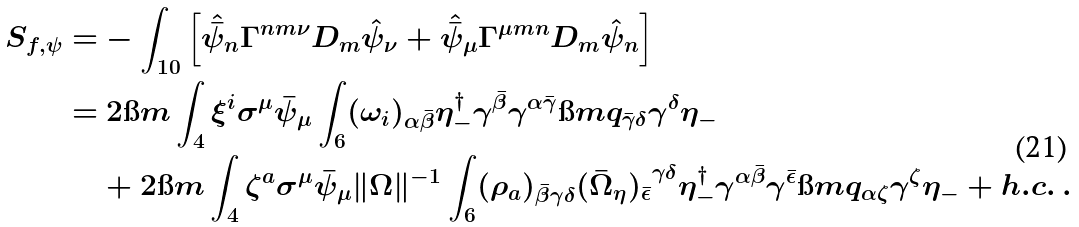<formula> <loc_0><loc_0><loc_500><loc_500>S _ { f , \psi } = & - \int _ { 1 0 } \left [ \hat { \bar { \psi } } _ { n } \Gamma ^ { n m \nu } D _ { m } \hat { \psi } _ { \nu } + \hat { \bar { \psi } } _ { \mu } \Gamma ^ { \mu m n } D _ { m } \hat { \psi } _ { n } \right ] \\ = & \ 2 \i m \int _ { 4 } \xi ^ { i } \sigma ^ { \mu } \bar { \psi } _ { \mu } \int _ { 6 } ( \omega _ { i } ) _ { \alpha \bar { \beta } } \eta ^ { \dag } _ { - } \gamma ^ { \bar { \beta } } \gamma ^ { \alpha \bar { \gamma } } \i m q _ { \bar { \gamma } \delta } \gamma ^ { \delta } \eta _ { - } \\ & + 2 \i m \int _ { 4 } \zeta ^ { a } \sigma ^ { \mu } \bar { \psi } _ { \mu } \| \Omega \| ^ { - 1 } \int _ { 6 } ( \rho _ { a } ) _ { \bar { \beta } \gamma \delta } { ( \bar { \Omega } _ { \eta } ) _ { \bar { \epsilon } } } ^ { \gamma \delta } \eta ^ { \dag } _ { - } \gamma ^ { \alpha \bar { \beta } } \gamma ^ { \bar { \epsilon } } \i m q _ { \alpha \zeta } \gamma ^ { \zeta } \eta _ { - } + h . c . \ .</formula> 